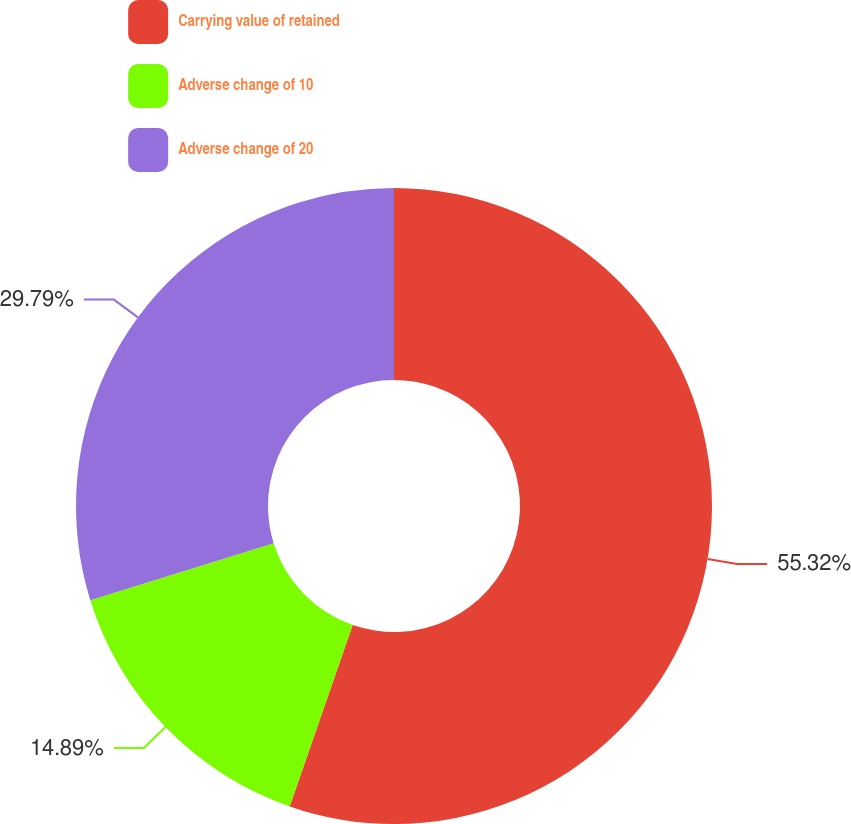Convert chart. <chart><loc_0><loc_0><loc_500><loc_500><pie_chart><fcel>Carrying value of retained<fcel>Adverse change of 10<fcel>Adverse change of 20<nl><fcel>55.32%<fcel>14.89%<fcel>29.79%<nl></chart> 